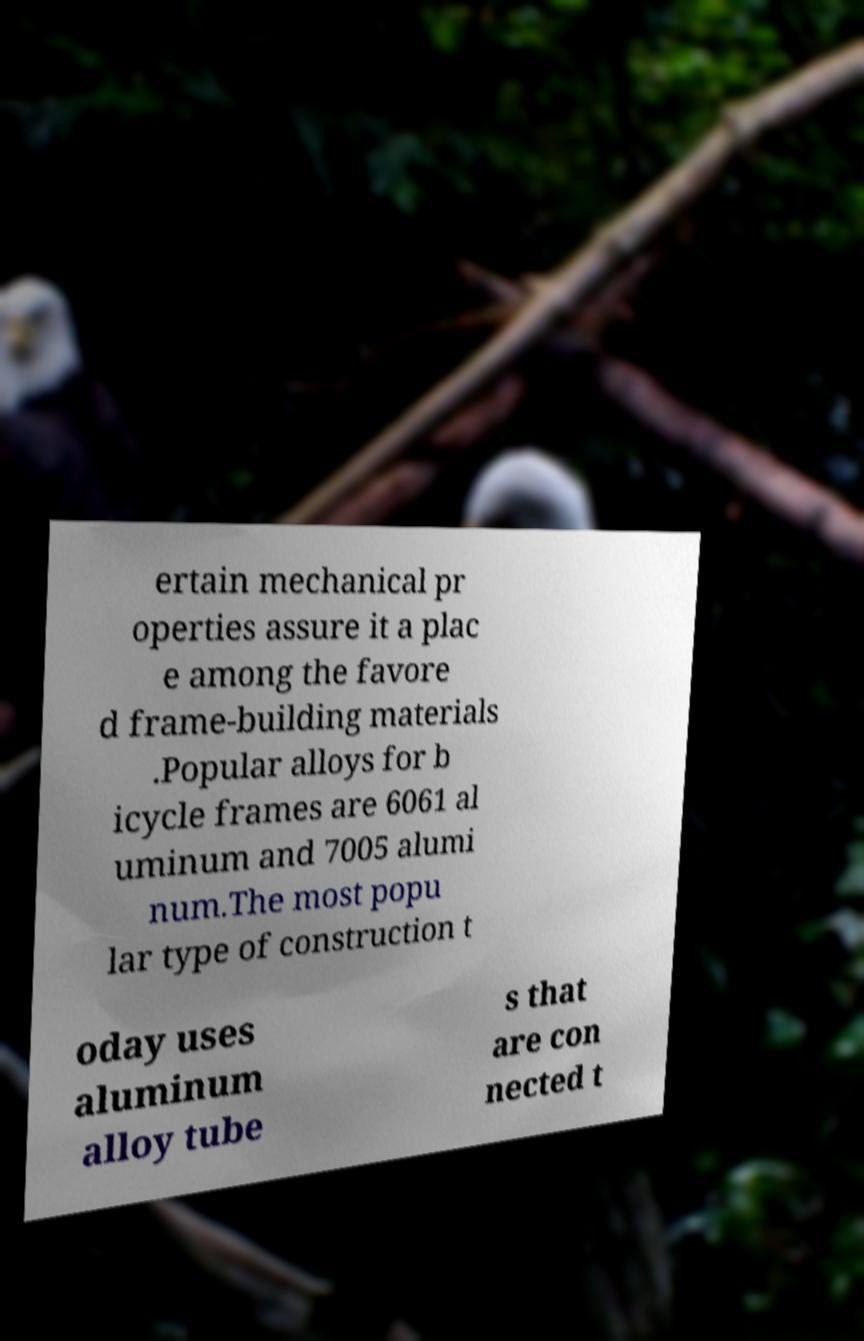There's text embedded in this image that I need extracted. Can you transcribe it verbatim? ertain mechanical pr operties assure it a plac e among the favore d frame-building materials .Popular alloys for b icycle frames are 6061 al uminum and 7005 alumi num.The most popu lar type of construction t oday uses aluminum alloy tube s that are con nected t 